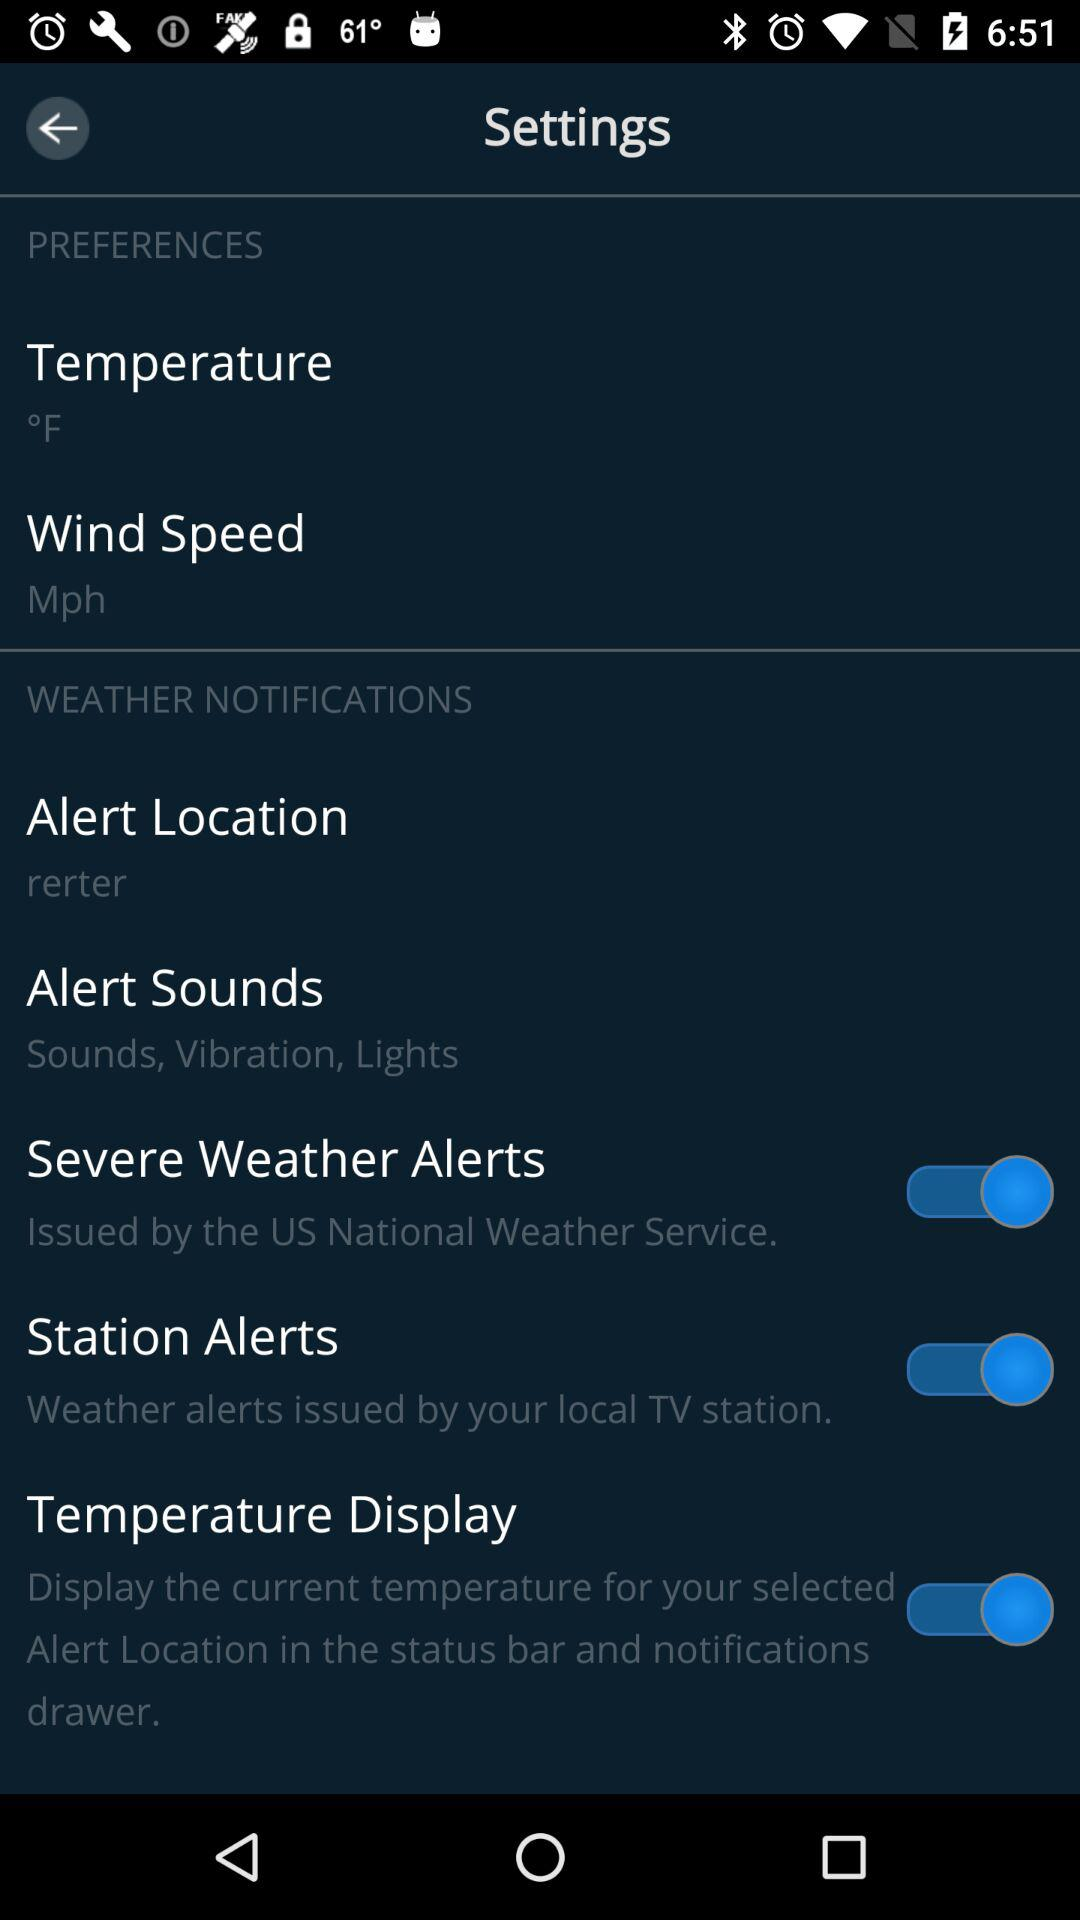How many more items are there in the Weather Notifications section than the Preferences section?
Answer the question using a single word or phrase. 3 